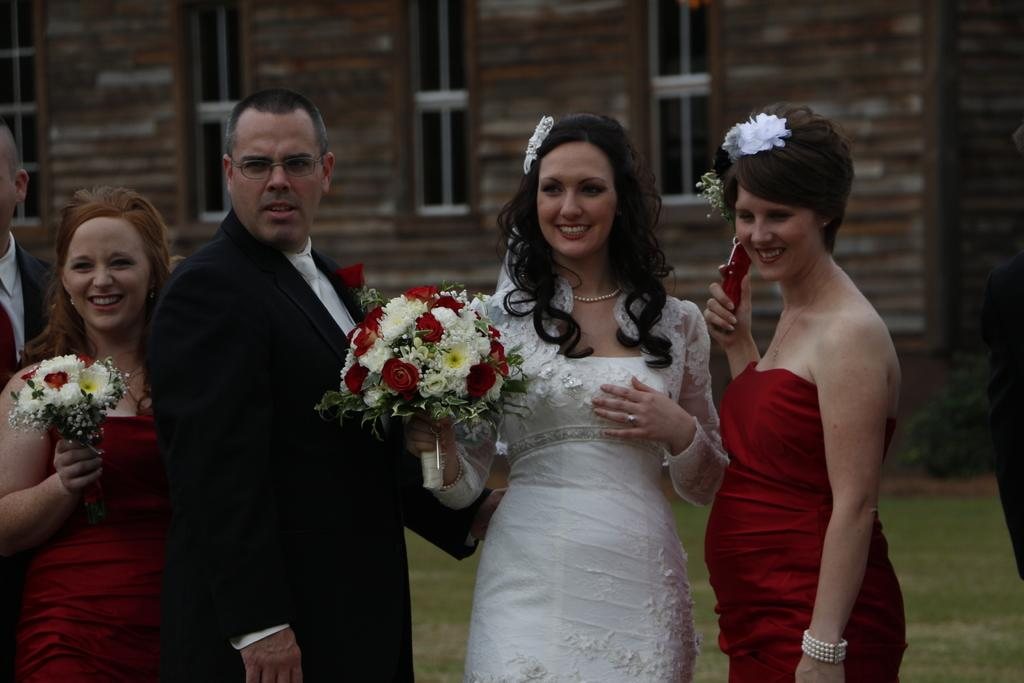How many people are present in the image? There are five persons standing in the image. What are two of the women holding? Two women are holding flower bouquets. What can be seen in the background of the image? There is a building in the background of the image. What feature of the building is visible in the image? Windows of the building are visible in the image. What type of pet can be seen sitting on the lap of one of the persons in the image? There is no pet visible in the image; only five persons and a building in the background are present. 